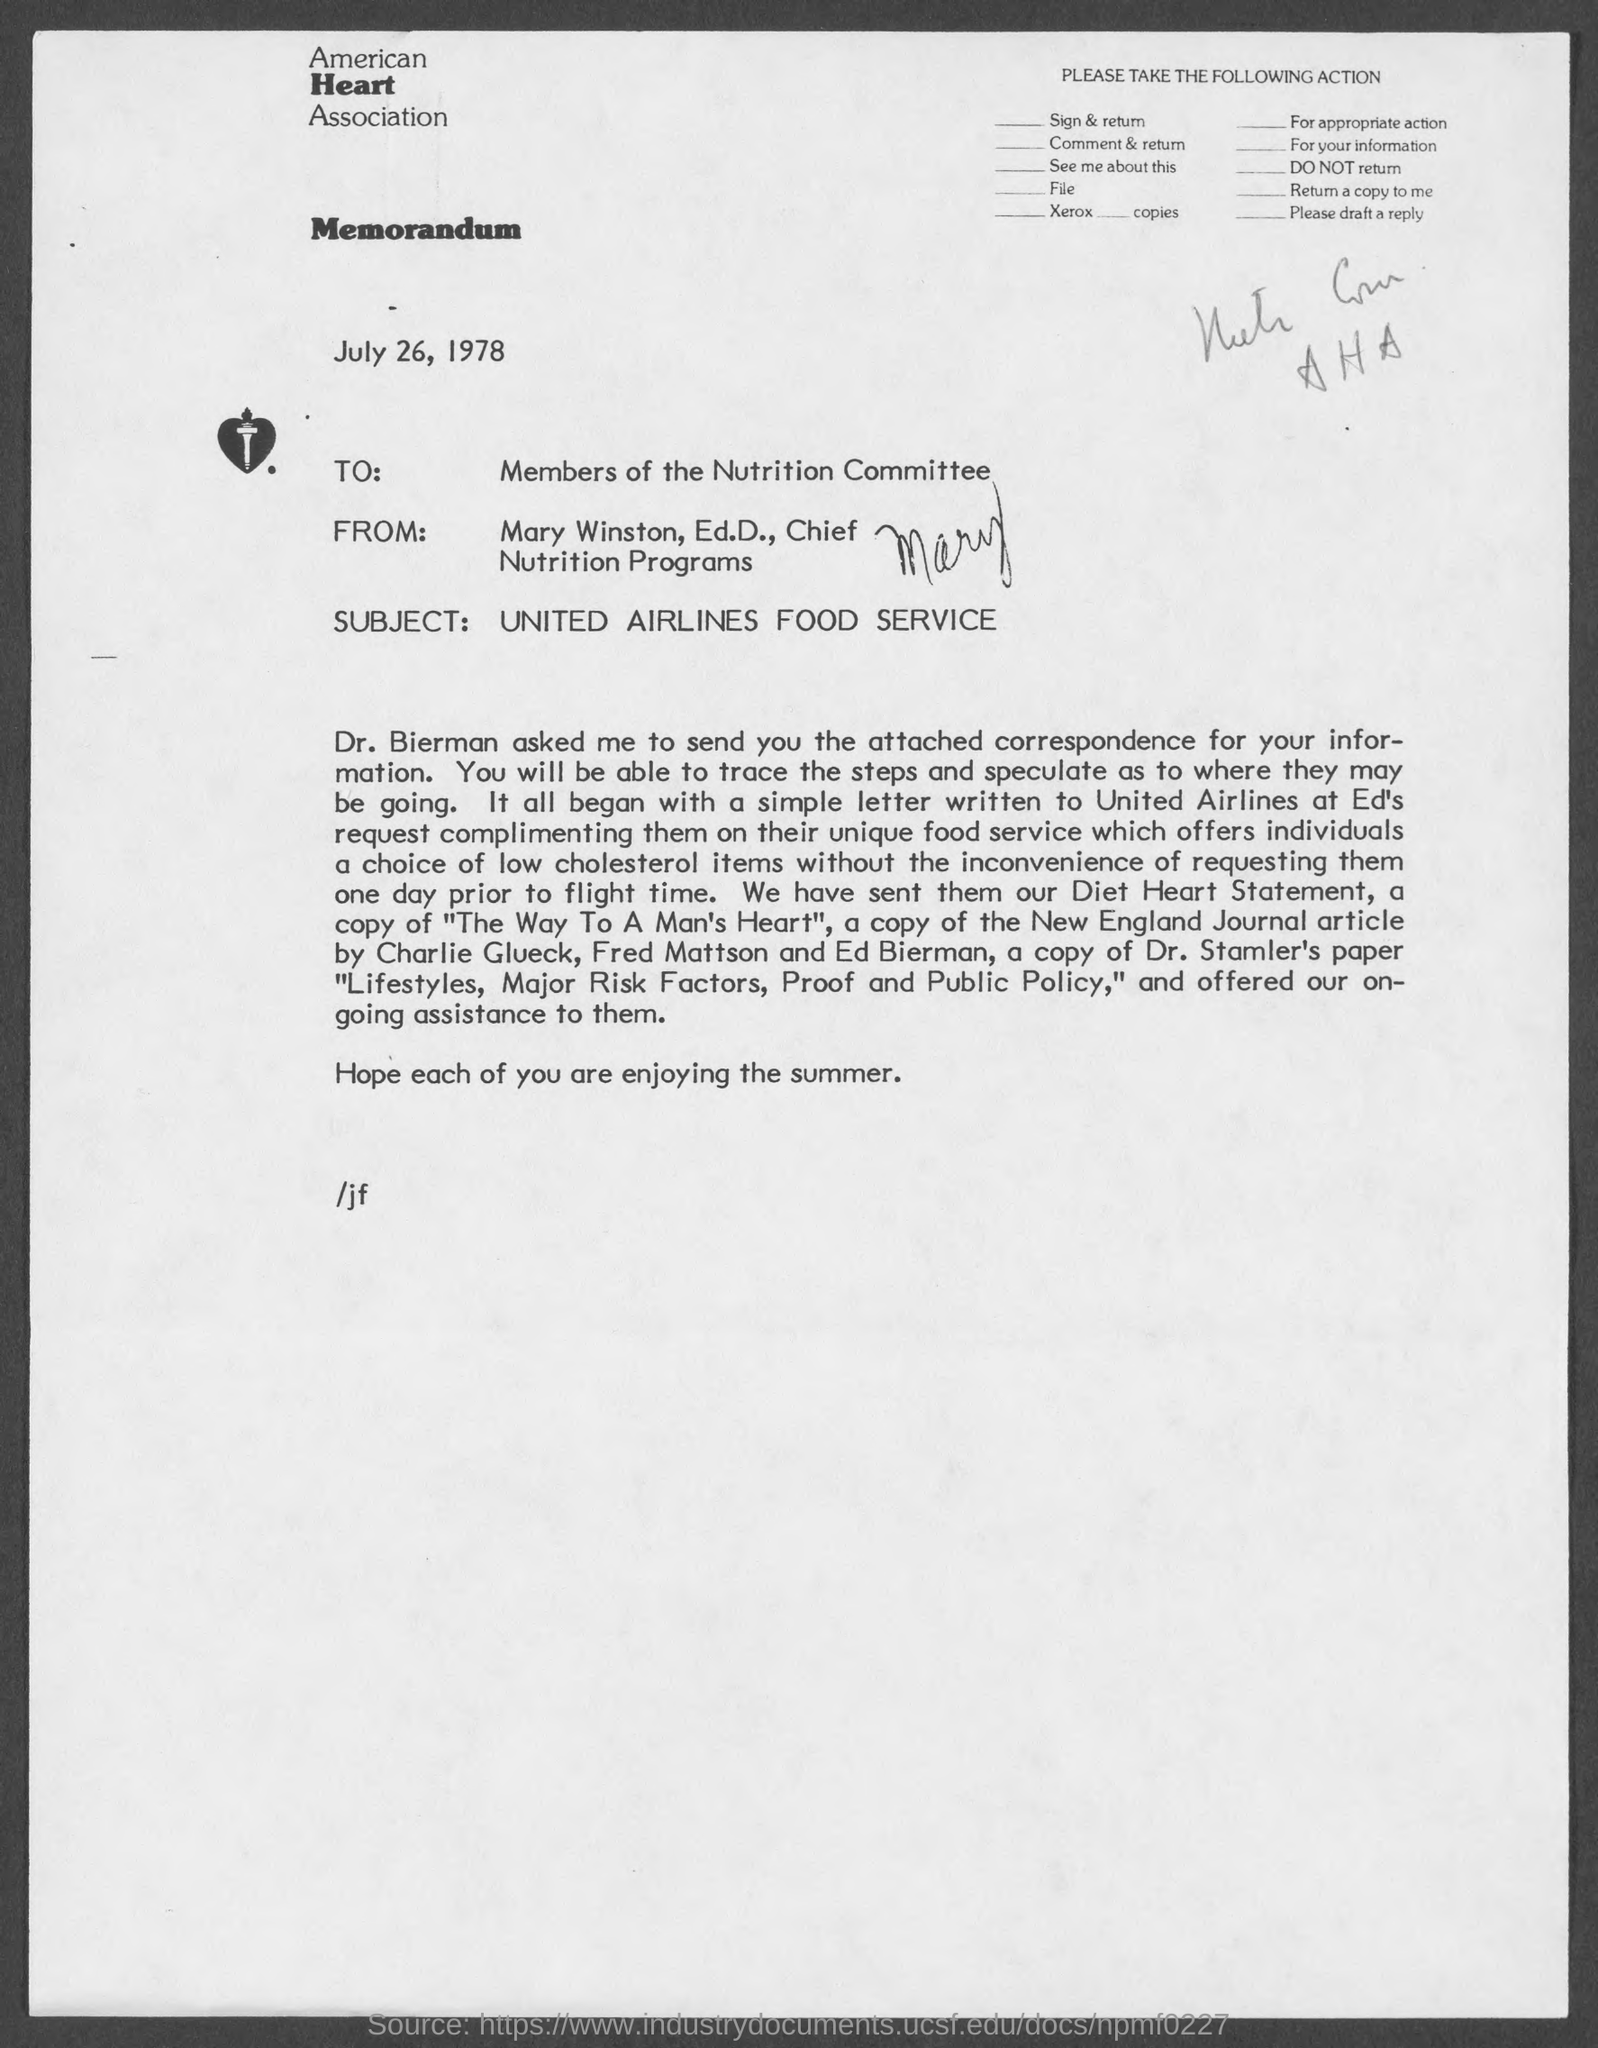What kind of communication is this ?
Offer a very short reply. Memorandum. Which association is mentioned in the letterhead?
Make the answer very short. American Heart Association. To whom, the memorandum is addressed?
Offer a terse response. Members of the Nutrition Committee. What is the subject mentioned in this memorandum?
Give a very brief answer. United Airlines Food Service. What is the date mentioned in the memorandum?
Your answer should be very brief. July 26, 1978. 